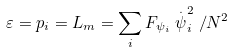Convert formula to latex. <formula><loc_0><loc_0><loc_500><loc_500>\varepsilon = p _ { i } = L _ { m } = \sum _ { i } F _ { \psi _ { i } } \stackrel { . } { \psi } _ { i } ^ { 2 } / N ^ { 2 }</formula> 